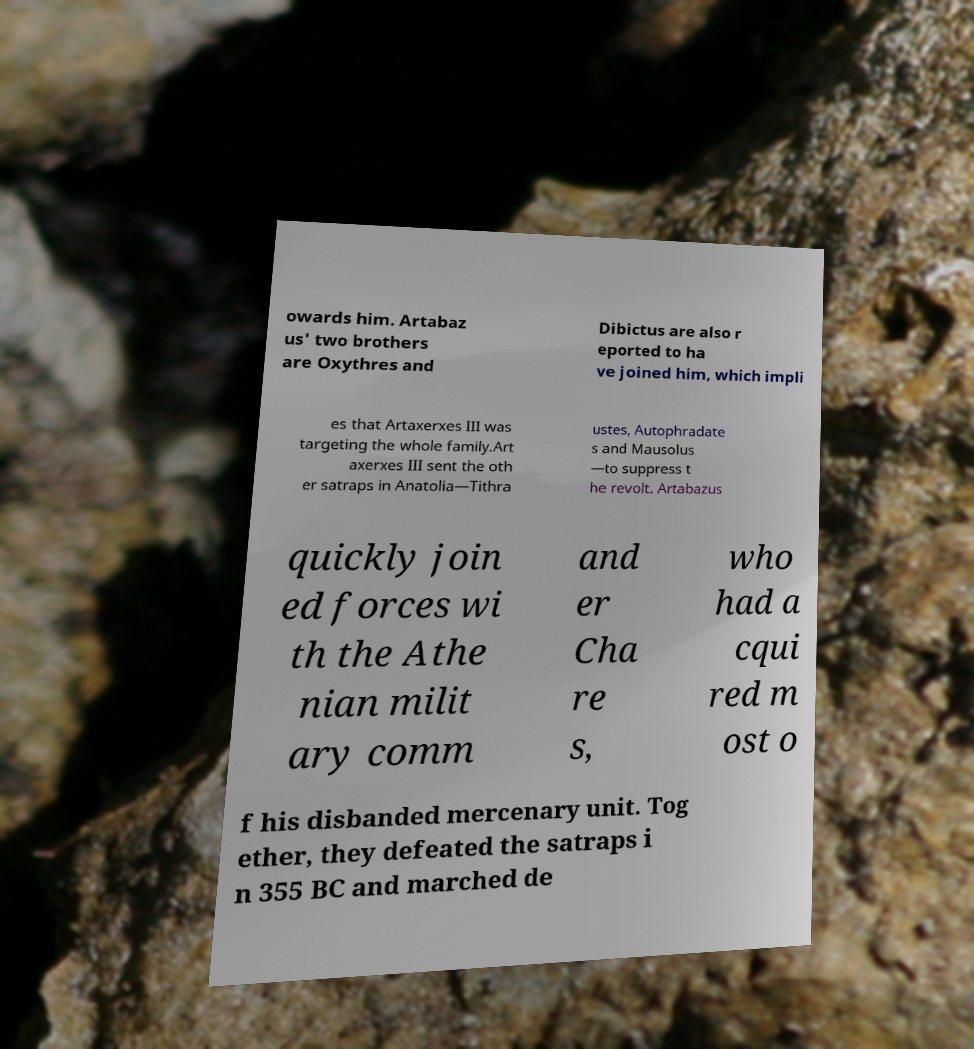Can you read and provide the text displayed in the image?This photo seems to have some interesting text. Can you extract and type it out for me? owards him. Artabaz us' two brothers are Oxythres and Dibictus are also r eported to ha ve joined him, which impli es that Artaxerxes III was targeting the whole family.Art axerxes III sent the oth er satraps in Anatolia—Tithra ustes, Autophradate s and Mausolus —to suppress t he revolt. Artabazus quickly join ed forces wi th the Athe nian milit ary comm and er Cha re s, who had a cqui red m ost o f his disbanded mercenary unit. Tog ether, they defeated the satraps i n 355 BC and marched de 